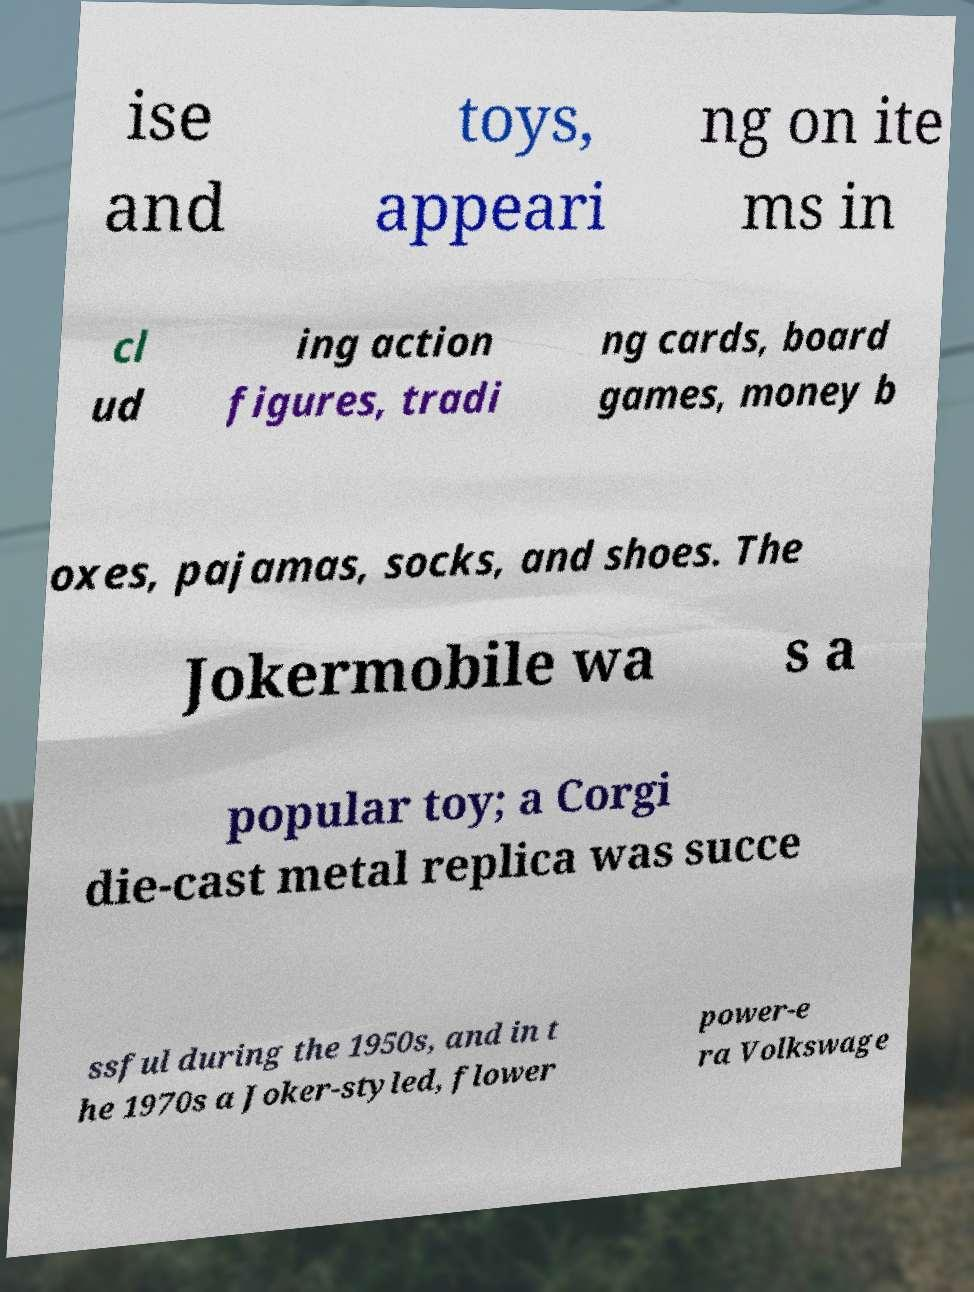There's text embedded in this image that I need extracted. Can you transcribe it verbatim? ise and toys, appeari ng on ite ms in cl ud ing action figures, tradi ng cards, board games, money b oxes, pajamas, socks, and shoes. The Jokermobile wa s a popular toy; a Corgi die-cast metal replica was succe ssful during the 1950s, and in t he 1970s a Joker-styled, flower power-e ra Volkswage 